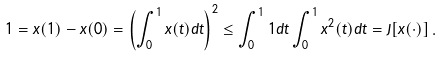Convert formula to latex. <formula><loc_0><loc_0><loc_500><loc_500>1 = x ( 1 ) - x ( 0 ) = \left ( \int _ { 0 } ^ { 1 } \dot { x } ( t ) d t \right ) ^ { 2 } \leq \int _ { 0 } ^ { 1 } 1 d t \int _ { 0 } ^ { 1 } \dot { x } ^ { 2 } ( t ) d t = J [ x ( \cdot ) ] \, .</formula> 